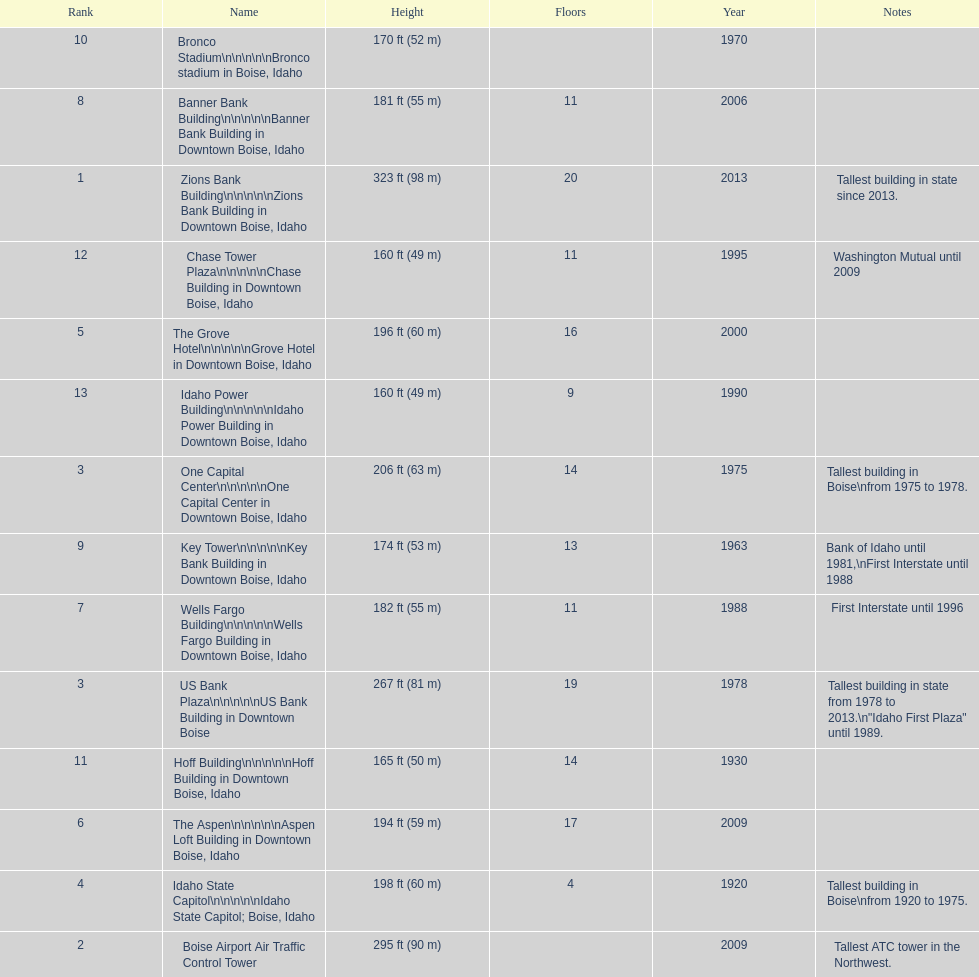Which building has the most floors according to this chart? Zions Bank Building. 